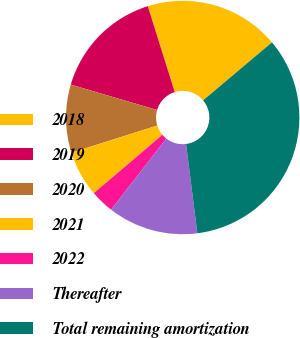Convert chart to OTSL. <chart><loc_0><loc_0><loc_500><loc_500><pie_chart><fcel>2018<fcel>2019<fcel>2020<fcel>2021<fcel>2022<fcel>Thereafter<fcel>Total remaining amortization<nl><fcel>18.7%<fcel>15.61%<fcel>9.43%<fcel>6.35%<fcel>3.26%<fcel>12.52%<fcel>34.13%<nl></chart> 